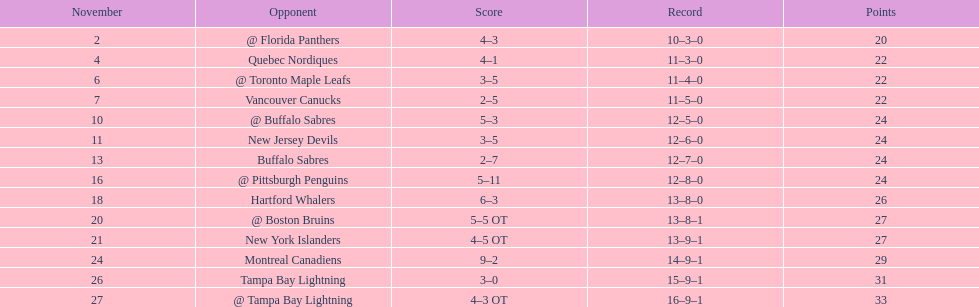Did the tampa bay lightning have the least amount of wins? Yes. 